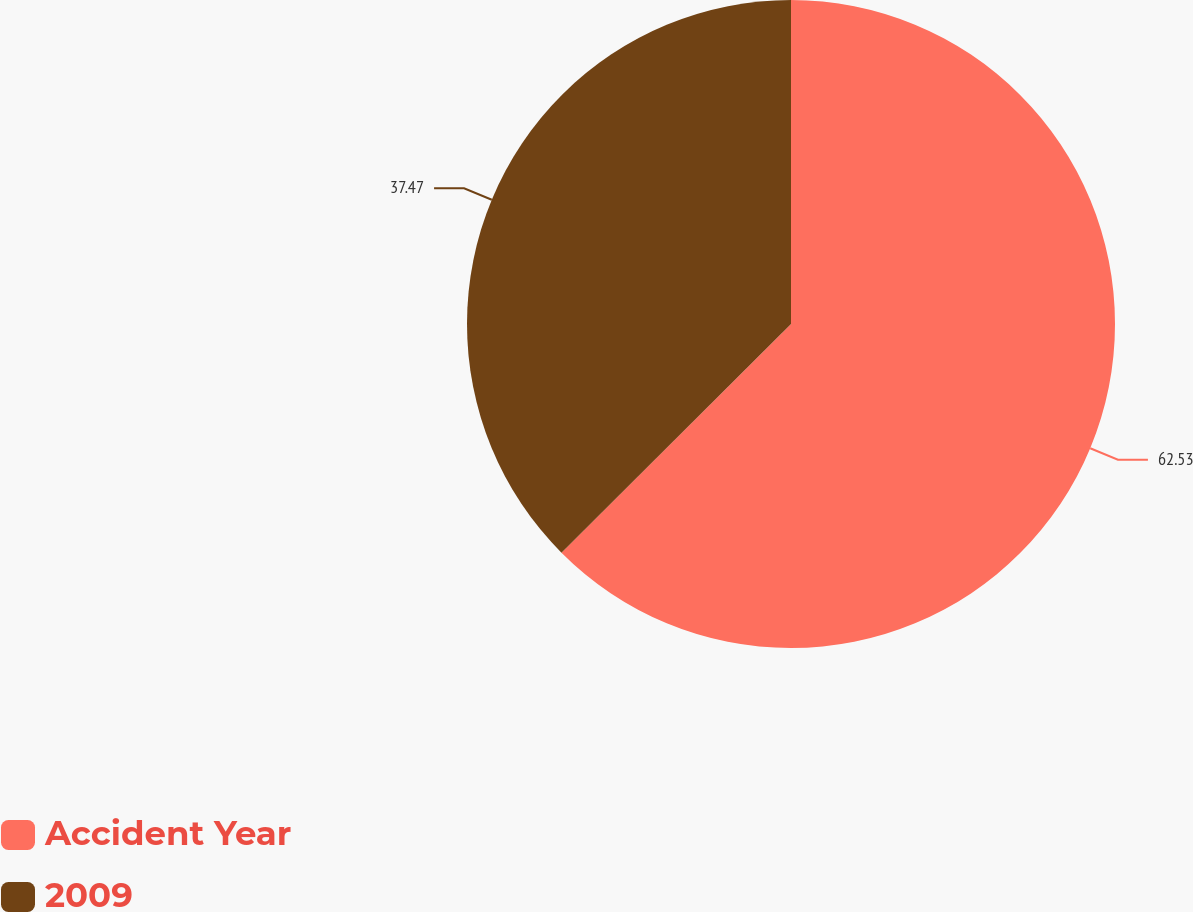<chart> <loc_0><loc_0><loc_500><loc_500><pie_chart><fcel>Accident Year<fcel>2009<nl><fcel>62.53%<fcel>37.47%<nl></chart> 